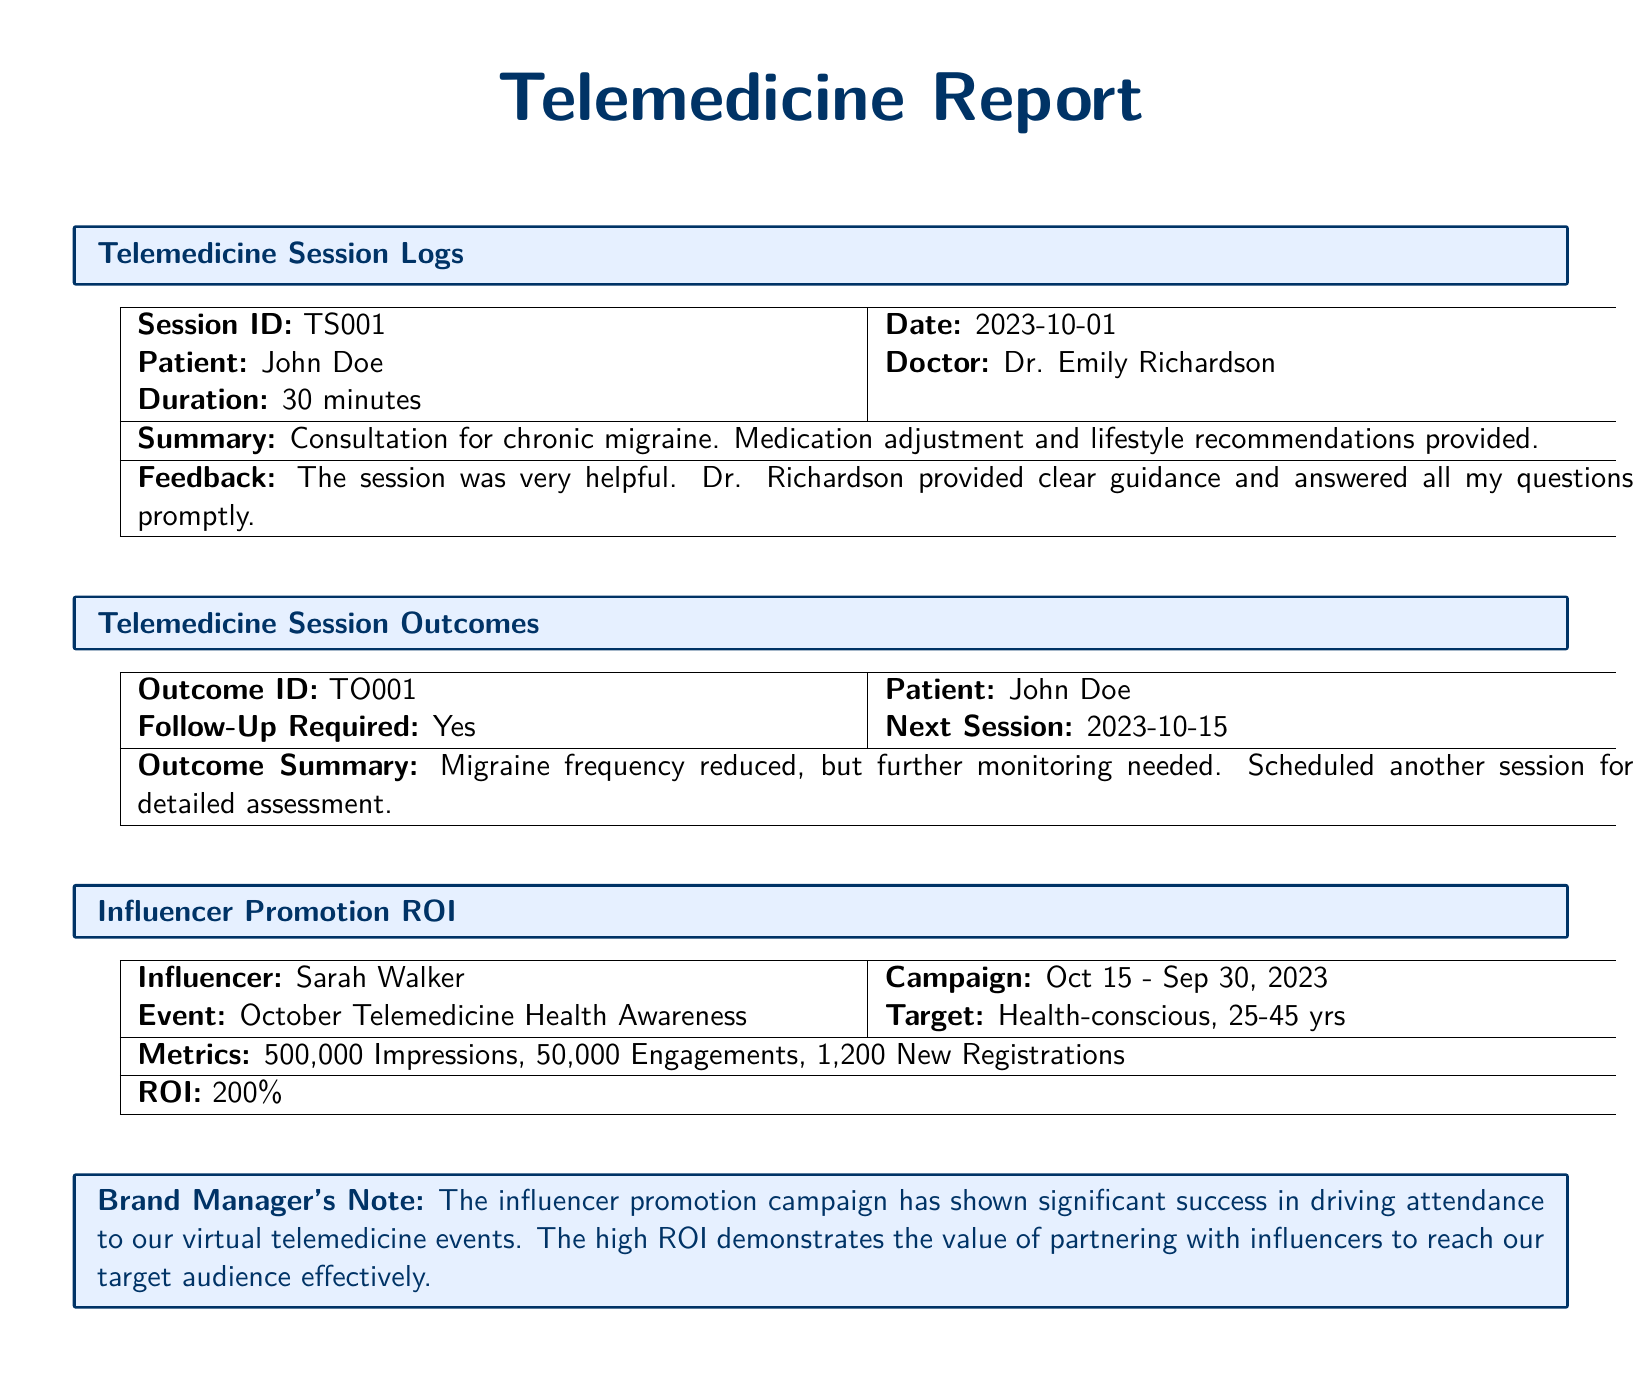What is the patient's name? The patient's name is recorded in the telemedicine session logs section of the document.
Answer: John Doe Who is the doctor? The doctor's name is listed along with the patient's information in the document.
Answer: Dr. Emily Richardson What date is the telemedicine session? The date of the session is specifically mentioned in the session logs.
Answer: 2023-10-01 What was the outcome of the session? The outcome summary is provided, indicating the results of the telemedicine session.
Answer: Migraine frequency reduced What is the next session date? The next session date is specified in the outcomes section for the patient.
Answer: 2023-10-15 How many new registrations resulted from the influencer promotion? The number of new registrations from the promotion campaign is listed in the ROI section.
Answer: 1,200 What was the ROI of the campaign? The ROI is highlighted in the influencer promotion ROI metrics.
Answer: 200% What is the target demographic for the influencer campaign? The target demographic is specified in the influencer promotion section.
Answer: Health-conscious, 25-45 yrs What feedback did the patient provide about the session? Patient feedback is summarized in the session logs section of the document.
Answer: The session was very helpful 